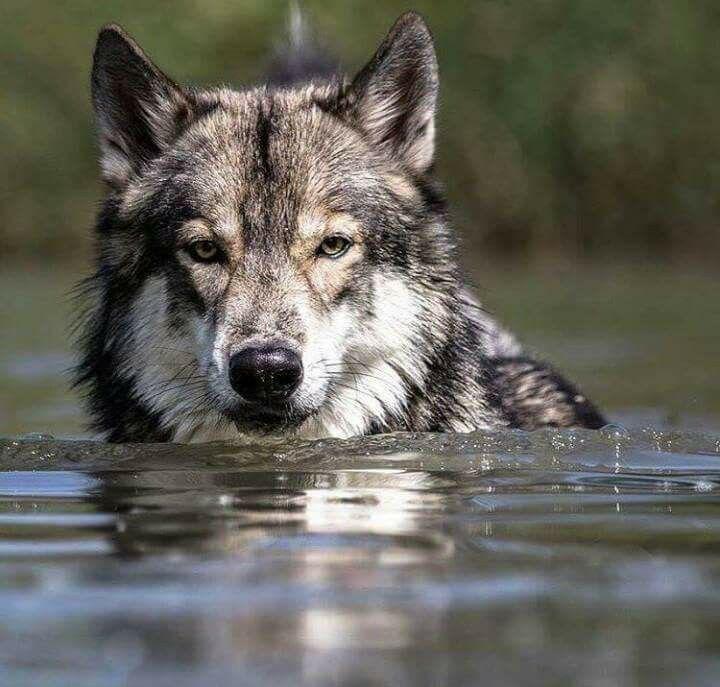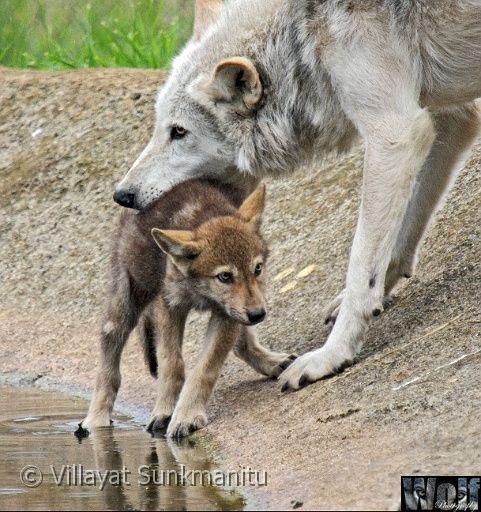The first image is the image on the left, the second image is the image on the right. For the images shown, is this caption "In the right image, one wolf has its open jaw around part of a wolf pup." true? Answer yes or no. Yes. The first image is the image on the left, the second image is the image on the right. Analyze the images presented: Is the assertion "There is a wolf in the water." valid? Answer yes or no. Yes. 